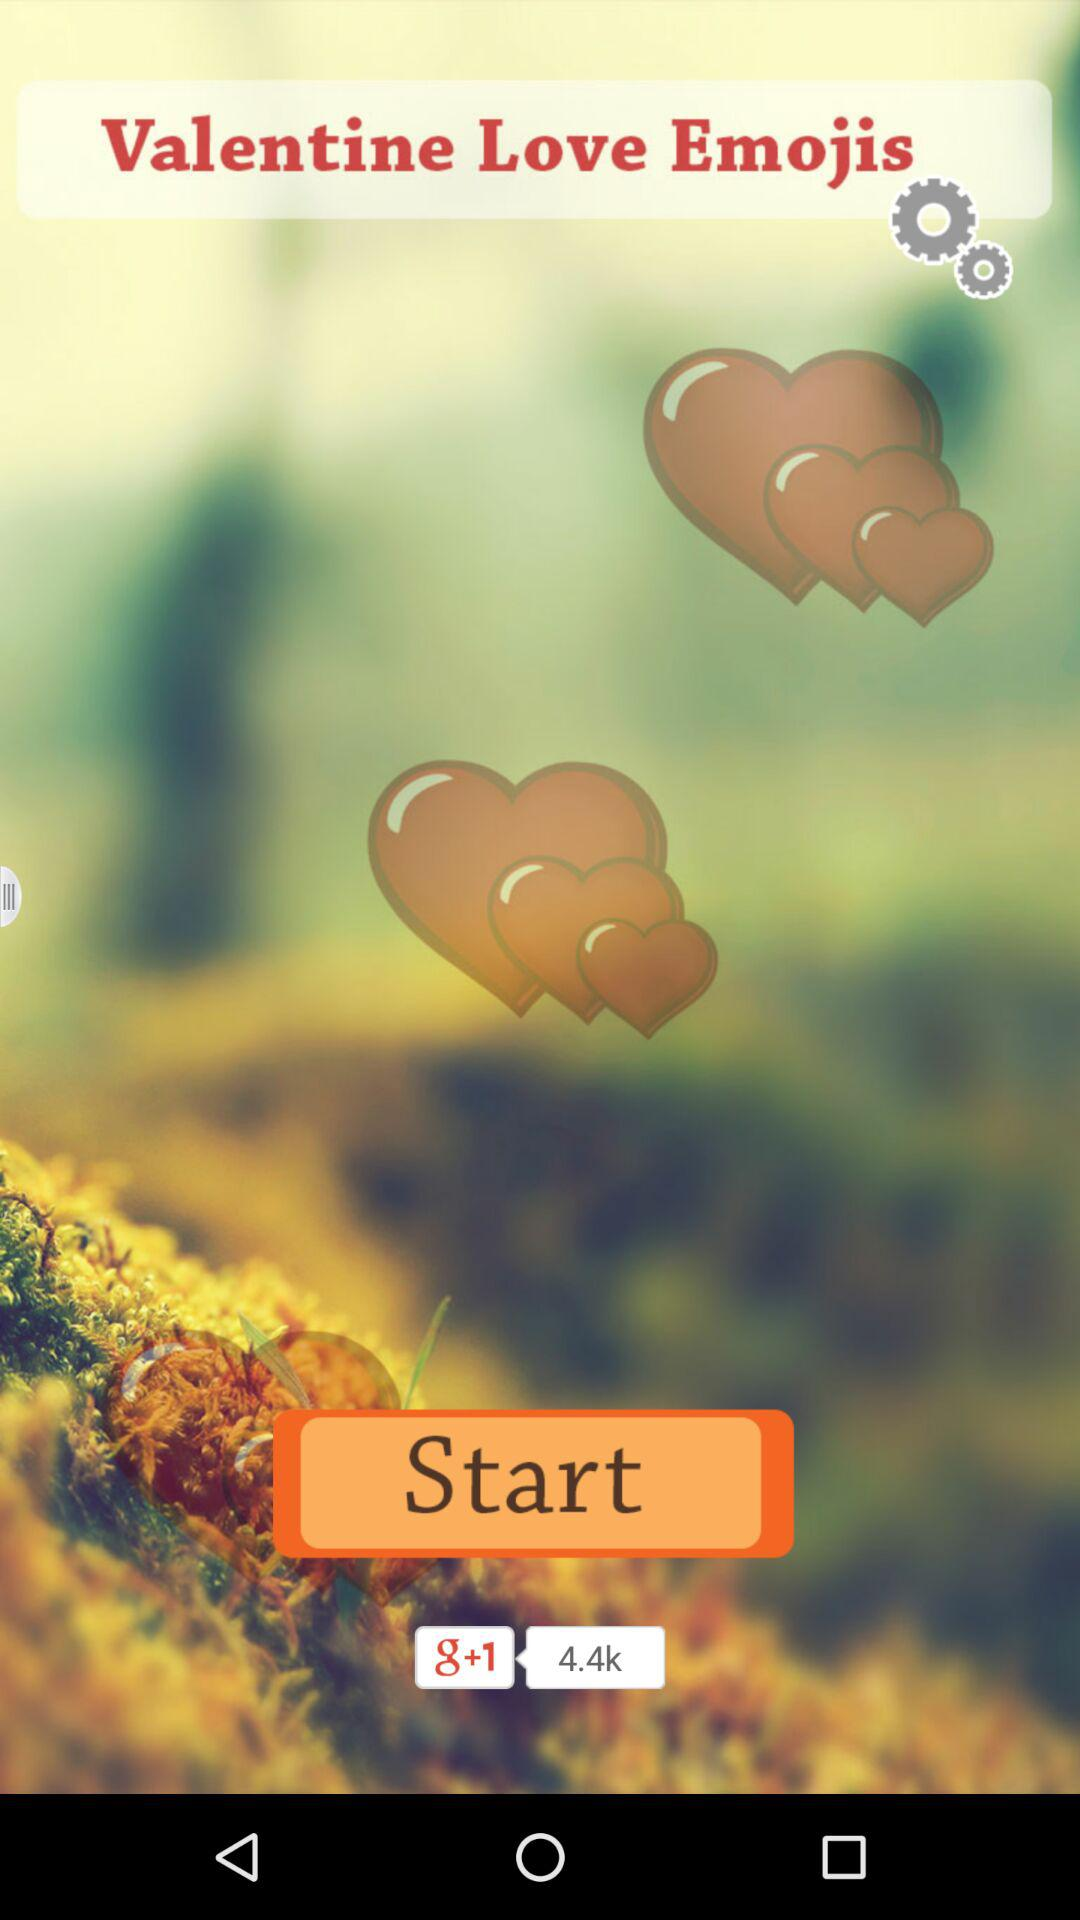How many likes on g+1?
When the provided information is insufficient, respond with <no answer>. <no answer> 